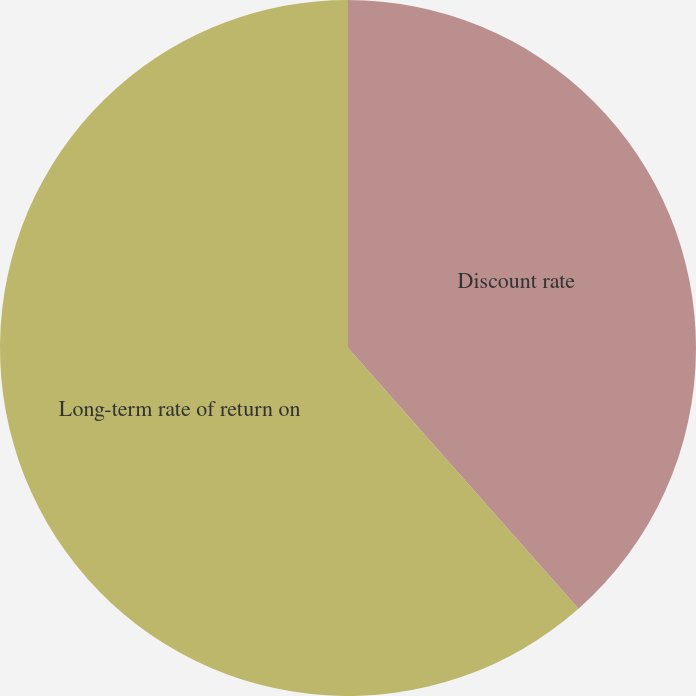Convert chart to OTSL. <chart><loc_0><loc_0><loc_500><loc_500><pie_chart><fcel>Discount rate<fcel>Long-term rate of return on<nl><fcel>38.48%<fcel>61.52%<nl></chart> 